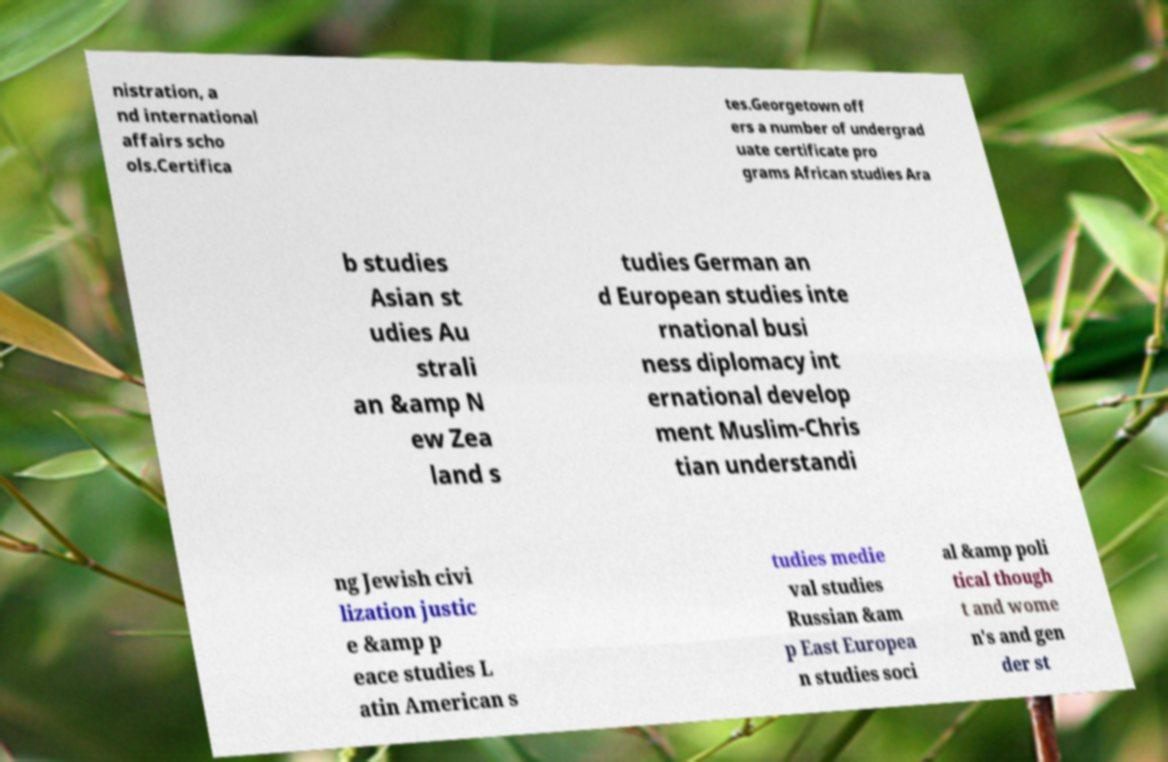What messages or text are displayed in this image? I need them in a readable, typed format. nistration, a nd international affairs scho ols.Certifica tes.Georgetown off ers a number of undergrad uate certificate pro grams African studies Ara b studies Asian st udies Au strali an &amp N ew Zea land s tudies German an d European studies inte rnational busi ness diplomacy int ernational develop ment Muslim-Chris tian understandi ng Jewish civi lization justic e &amp p eace studies L atin American s tudies medie val studies Russian &am p East Europea n studies soci al &amp poli tical though t and wome n's and gen der st 